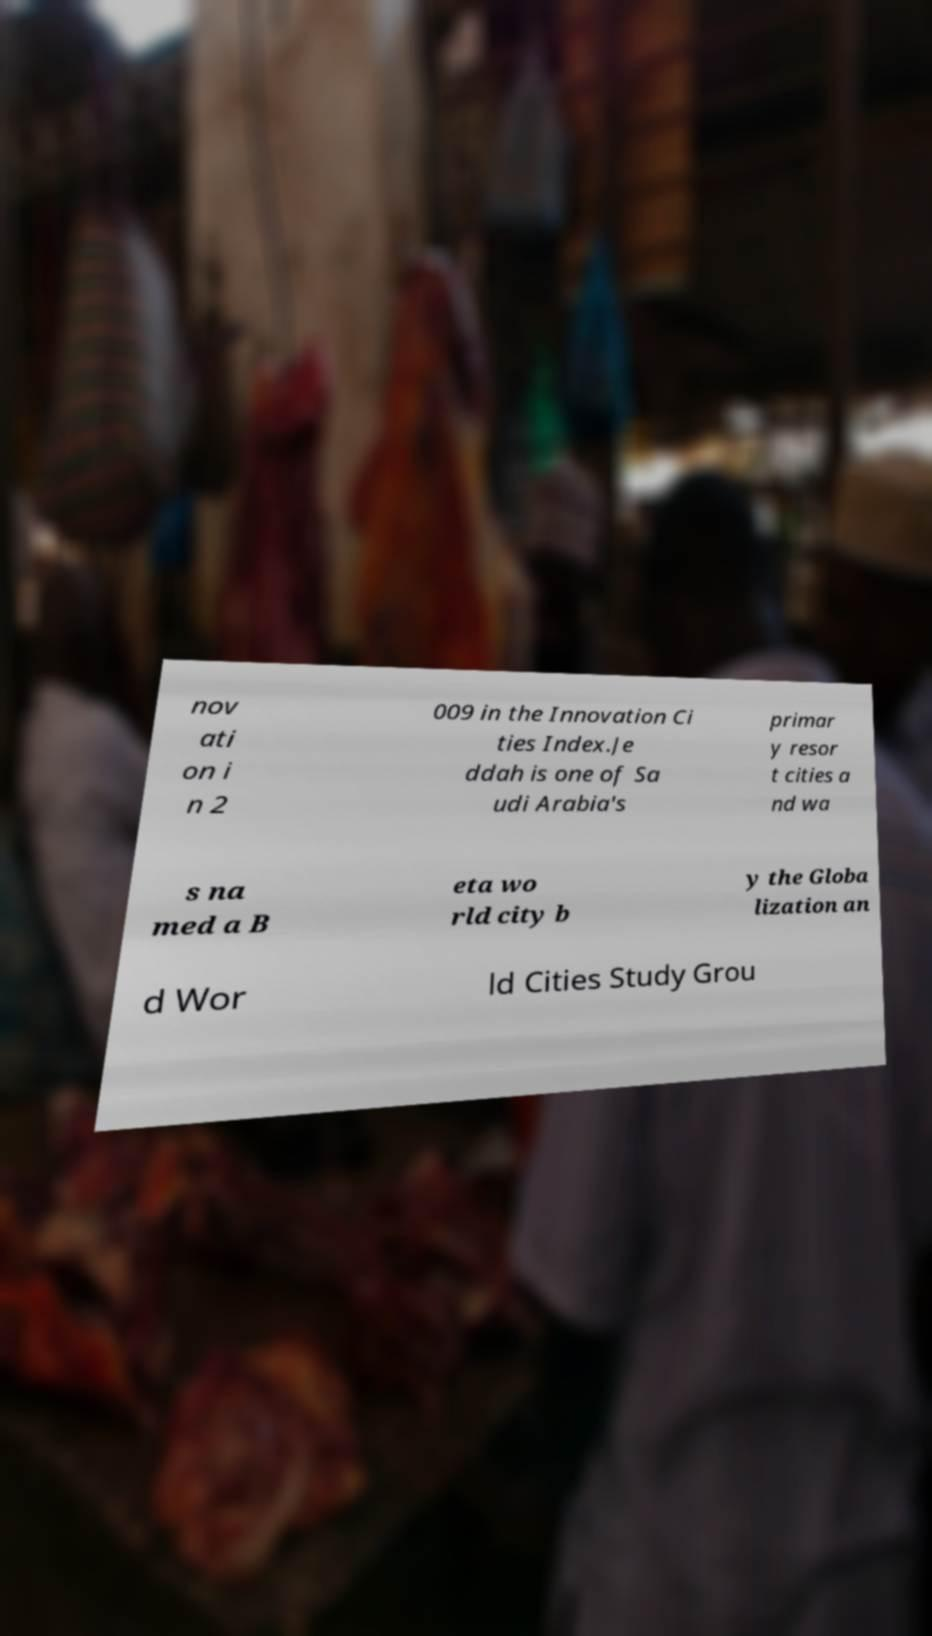Could you extract and type out the text from this image? nov ati on i n 2 009 in the Innovation Ci ties Index.Je ddah is one of Sa udi Arabia's primar y resor t cities a nd wa s na med a B eta wo rld city b y the Globa lization an d Wor ld Cities Study Grou 